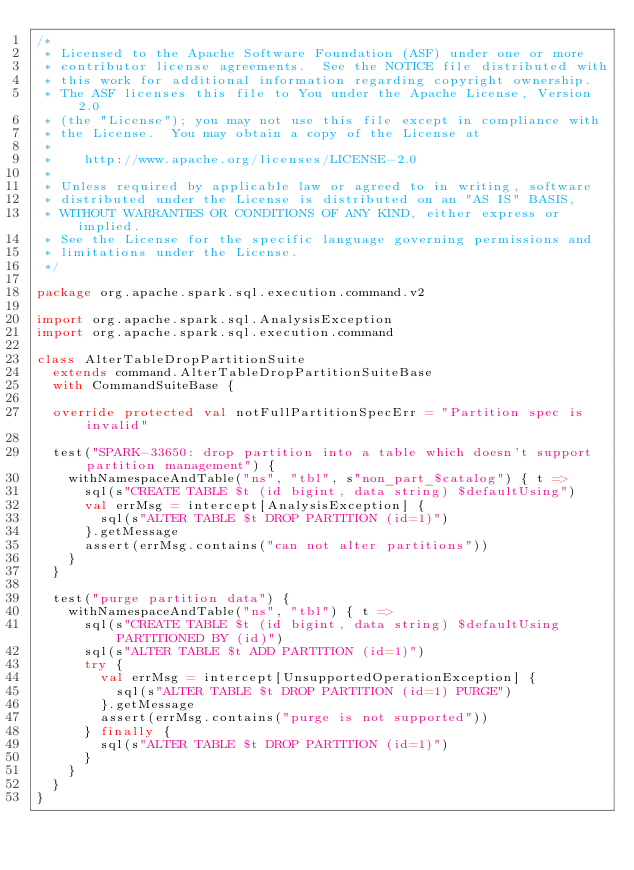Convert code to text. <code><loc_0><loc_0><loc_500><loc_500><_Scala_>/*
 * Licensed to the Apache Software Foundation (ASF) under one or more
 * contributor license agreements.  See the NOTICE file distributed with
 * this work for additional information regarding copyright ownership.
 * The ASF licenses this file to You under the Apache License, Version 2.0
 * (the "License"); you may not use this file except in compliance with
 * the License.  You may obtain a copy of the License at
 *
 *    http://www.apache.org/licenses/LICENSE-2.0
 *
 * Unless required by applicable law or agreed to in writing, software
 * distributed under the License is distributed on an "AS IS" BASIS,
 * WITHOUT WARRANTIES OR CONDITIONS OF ANY KIND, either express or implied.
 * See the License for the specific language governing permissions and
 * limitations under the License.
 */

package org.apache.spark.sql.execution.command.v2

import org.apache.spark.sql.AnalysisException
import org.apache.spark.sql.execution.command

class AlterTableDropPartitionSuite
  extends command.AlterTableDropPartitionSuiteBase
  with CommandSuiteBase {

  override protected val notFullPartitionSpecErr = "Partition spec is invalid"

  test("SPARK-33650: drop partition into a table which doesn't support partition management") {
    withNamespaceAndTable("ns", "tbl", s"non_part_$catalog") { t =>
      sql(s"CREATE TABLE $t (id bigint, data string) $defaultUsing")
      val errMsg = intercept[AnalysisException] {
        sql(s"ALTER TABLE $t DROP PARTITION (id=1)")
      }.getMessage
      assert(errMsg.contains("can not alter partitions"))
    }
  }

  test("purge partition data") {
    withNamespaceAndTable("ns", "tbl") { t =>
      sql(s"CREATE TABLE $t (id bigint, data string) $defaultUsing PARTITIONED BY (id)")
      sql(s"ALTER TABLE $t ADD PARTITION (id=1)")
      try {
        val errMsg = intercept[UnsupportedOperationException] {
          sql(s"ALTER TABLE $t DROP PARTITION (id=1) PURGE")
        }.getMessage
        assert(errMsg.contains("purge is not supported"))
      } finally {
        sql(s"ALTER TABLE $t DROP PARTITION (id=1)")
      }
    }
  }
}
</code> 